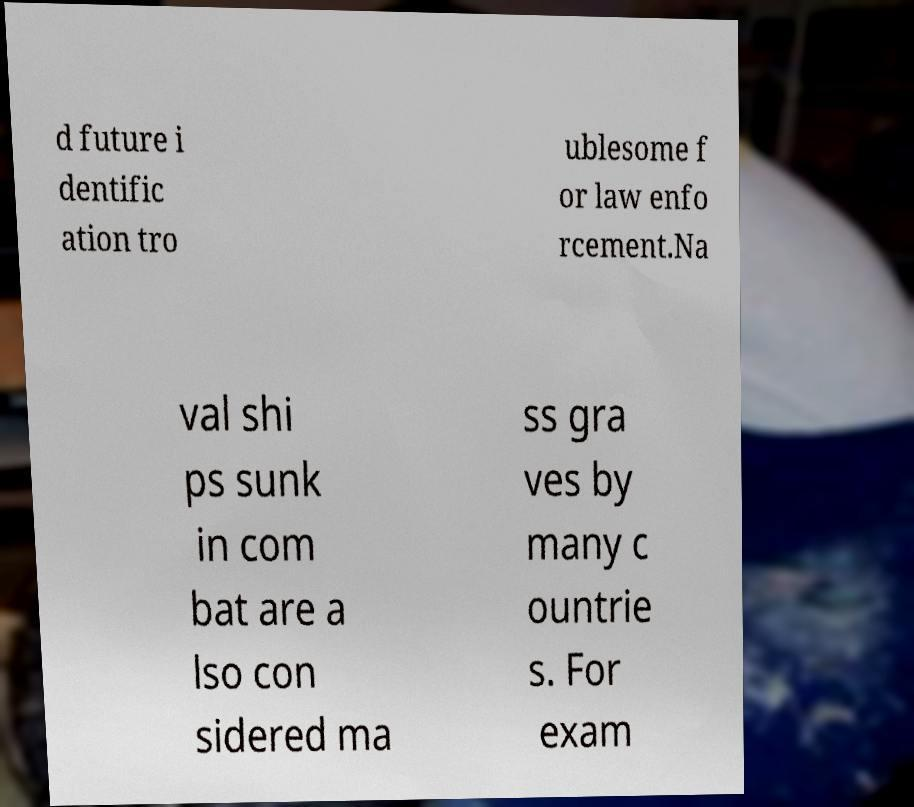Can you accurately transcribe the text from the provided image for me? d future i dentific ation tro ublesome f or law enfo rcement.Na val shi ps sunk in com bat are a lso con sidered ma ss gra ves by many c ountrie s. For exam 